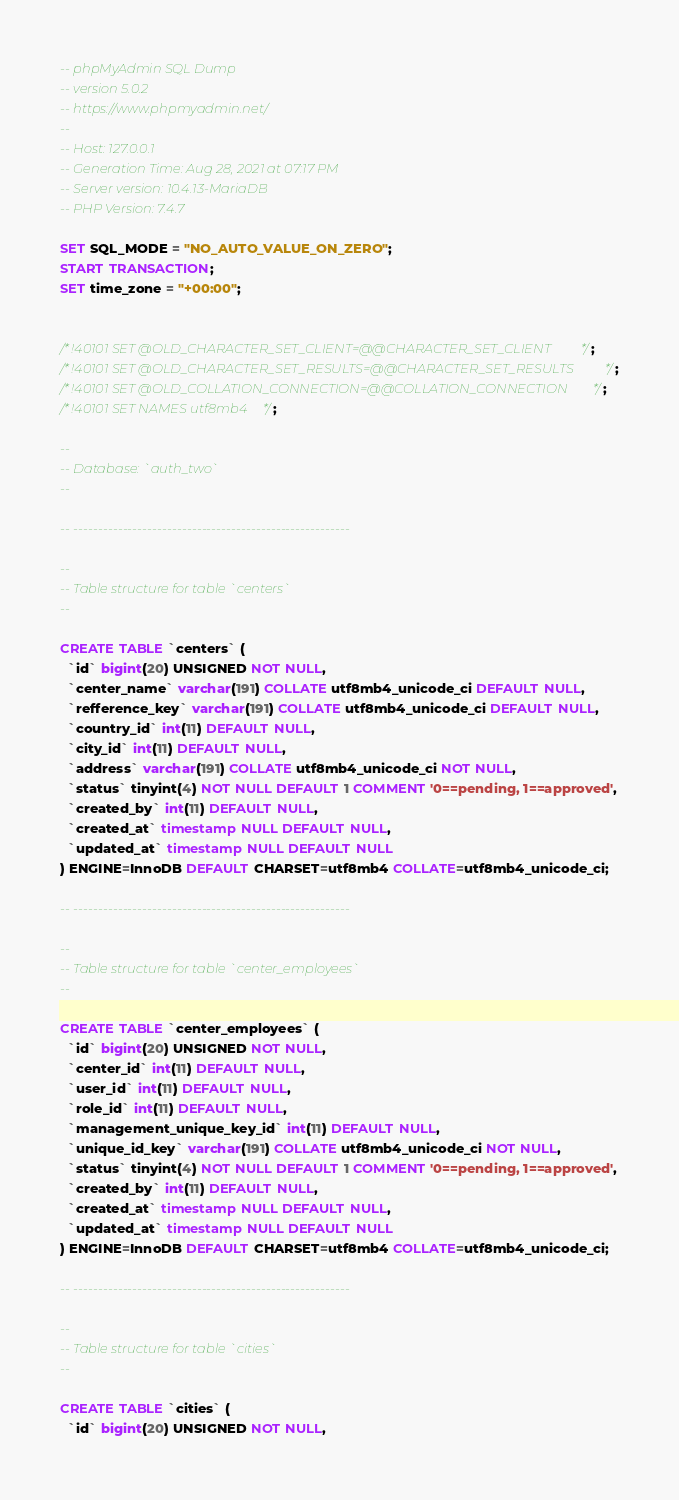<code> <loc_0><loc_0><loc_500><loc_500><_SQL_>-- phpMyAdmin SQL Dump
-- version 5.0.2
-- https://www.phpmyadmin.net/
--
-- Host: 127.0.0.1
-- Generation Time: Aug 28, 2021 at 07:17 PM
-- Server version: 10.4.13-MariaDB
-- PHP Version: 7.4.7

SET SQL_MODE = "NO_AUTO_VALUE_ON_ZERO";
START TRANSACTION;
SET time_zone = "+00:00";


/*!40101 SET @OLD_CHARACTER_SET_CLIENT=@@CHARACTER_SET_CLIENT */;
/*!40101 SET @OLD_CHARACTER_SET_RESULTS=@@CHARACTER_SET_RESULTS */;
/*!40101 SET @OLD_COLLATION_CONNECTION=@@COLLATION_CONNECTION */;
/*!40101 SET NAMES utf8mb4 */;

--
-- Database: `auth_two`
--

-- --------------------------------------------------------

--
-- Table structure for table `centers`
--

CREATE TABLE `centers` (
  `id` bigint(20) UNSIGNED NOT NULL,
  `center_name` varchar(191) COLLATE utf8mb4_unicode_ci DEFAULT NULL,
  `refference_key` varchar(191) COLLATE utf8mb4_unicode_ci DEFAULT NULL,
  `country_id` int(11) DEFAULT NULL,
  `city_id` int(11) DEFAULT NULL,
  `address` varchar(191) COLLATE utf8mb4_unicode_ci NOT NULL,
  `status` tinyint(4) NOT NULL DEFAULT 1 COMMENT '0==pending, 1==approved',
  `created_by` int(11) DEFAULT NULL,
  `created_at` timestamp NULL DEFAULT NULL,
  `updated_at` timestamp NULL DEFAULT NULL
) ENGINE=InnoDB DEFAULT CHARSET=utf8mb4 COLLATE=utf8mb4_unicode_ci;

-- --------------------------------------------------------

--
-- Table structure for table `center_employees`
--

CREATE TABLE `center_employees` (
  `id` bigint(20) UNSIGNED NOT NULL,
  `center_id` int(11) DEFAULT NULL,
  `user_id` int(11) DEFAULT NULL,
  `role_id` int(11) DEFAULT NULL,
  `management_unique_key_id` int(11) DEFAULT NULL,
  `unique_id_key` varchar(191) COLLATE utf8mb4_unicode_ci NOT NULL,
  `status` tinyint(4) NOT NULL DEFAULT 1 COMMENT '0==pending, 1==approved',
  `created_by` int(11) DEFAULT NULL,
  `created_at` timestamp NULL DEFAULT NULL,
  `updated_at` timestamp NULL DEFAULT NULL
) ENGINE=InnoDB DEFAULT CHARSET=utf8mb4 COLLATE=utf8mb4_unicode_ci;

-- --------------------------------------------------------

--
-- Table structure for table `cities`
--

CREATE TABLE `cities` (
  `id` bigint(20) UNSIGNED NOT NULL,</code> 